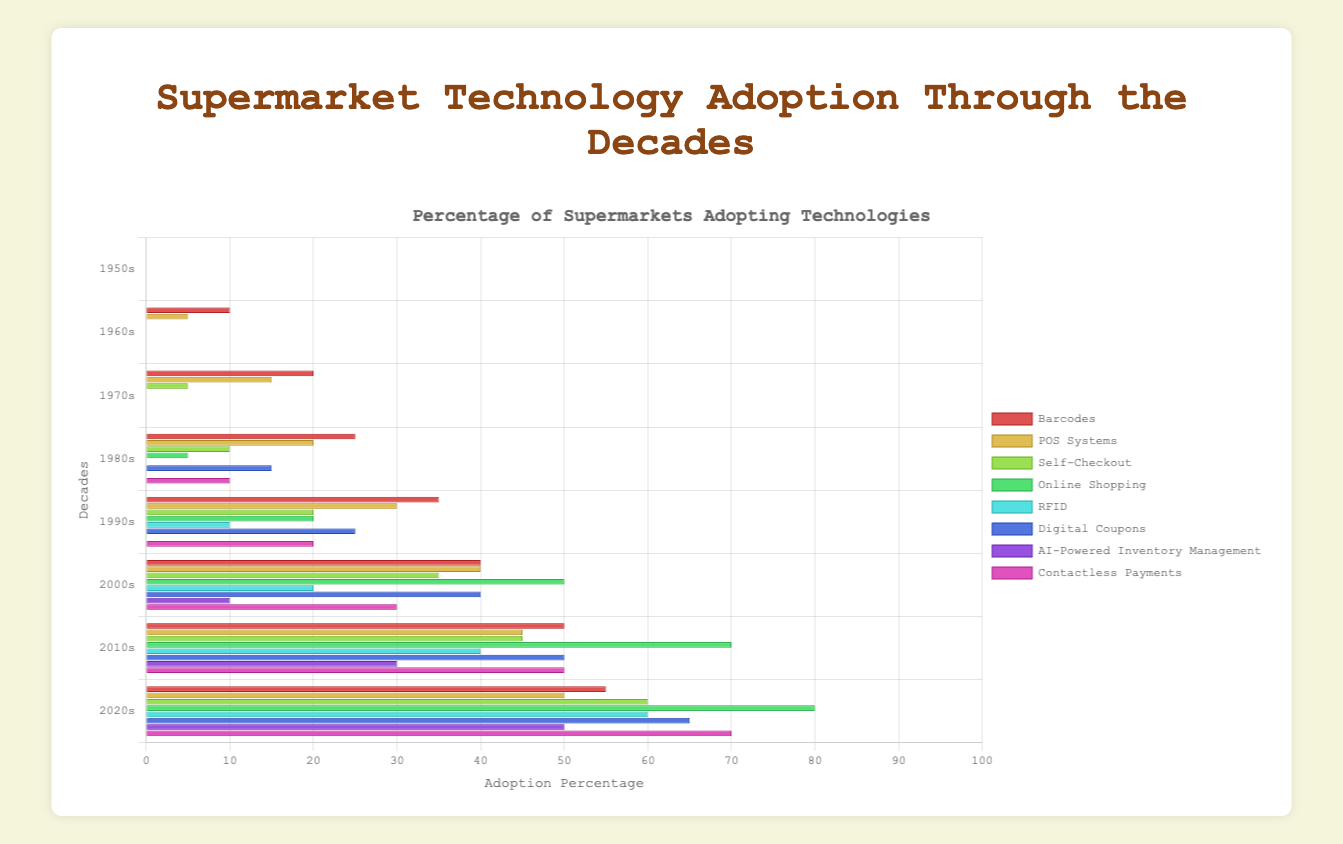What was the adoption rate of Barcodes by the 1990s? The Barcodes adoption rate in the 1990s can be directly read off from the data for that decade. It was 35%.
Answer: 35% Which technology saw the greatest increase in adoption rate from 2000s to 2010s? Compare the increase in adoption rates for each technology between the 2000s and 2010s. Barcodes increased by 10%, POS Systems by 5%, Self-Checkout by 10%, Online Shopping by 20%, RFID by 20%, Digital Coupons by 10%, AI-Powered Inventory Management by 20%, Contactless Payments by 20%. Online Shopping, RFID, AI-Powered Inventory Management, and Contactless Payments all saw a 20% increase, the largest increase.
Answer: Online Shopping, RFID, AI-Powered Inventory Management, Contactless Payments How many years after the first appearance of Barcodes did RFID first start getting adopted? Barcodes appeared in the 1960s and RFID appeared in the 1990s. The difference between these decades is 1990-1960 = 30 years.
Answer: 30 years What is the overall trend in the adoption of Digital Coupons from the 1990s to the 2020s? The adoption rate of Digital Coupons from the 1990s (25%) to the 2020s (65%) increases steadily.
Answer: Increasing In which decade did Self-Checkout surpass a 30% adoption rate? Identify the decade when the adoption rate of Self-Checkout first exceeded 30%. This happened in the 2000s (35%).
Answer: 2000s Which technology had the highest adoption rate in the 2020s? Compare the adoption rates of all technologies in the 2020s. Online Shopping had the highest adoption rate at 80%.
Answer: Online Shopping By how much did the adoption rate of Contactless Payments increase from the 1990s to the 2020s? The adoption rate of Contactless Payments increased from 20% in the 1990s to 70% in the 2020s. Calculate the difference: 70% - 20% = 50%.
Answer: 50% What is the combined adoption rate of RFID and AI-Powered Inventory Management in the 2010s? Add the adoption rates of RFID (40%) and AI-Powered Inventory Management (30%) in the 2010s: 40 + 30 = 70%.
Answer: 70% Which decade saw the introduction of the most new technologies? Count the number of technologies first introduced in each decade. The 1990s saw the introduction of 3 new technologies: Online Shopping, RFID, and Contactless Payments.
Answer: 1990s Which technology had the smallest growth in adoption from the 1970s to the 1980s? Calculate the growth in adoption for each technology from the 1970s to the 1980s and find the smallest difference. Barcodes grew by 5%, POS Systems by 5%, Self-Checkout by 5%. The smallest increase was for Self-Checkout at 5%.
Answer: Self-Checkout 